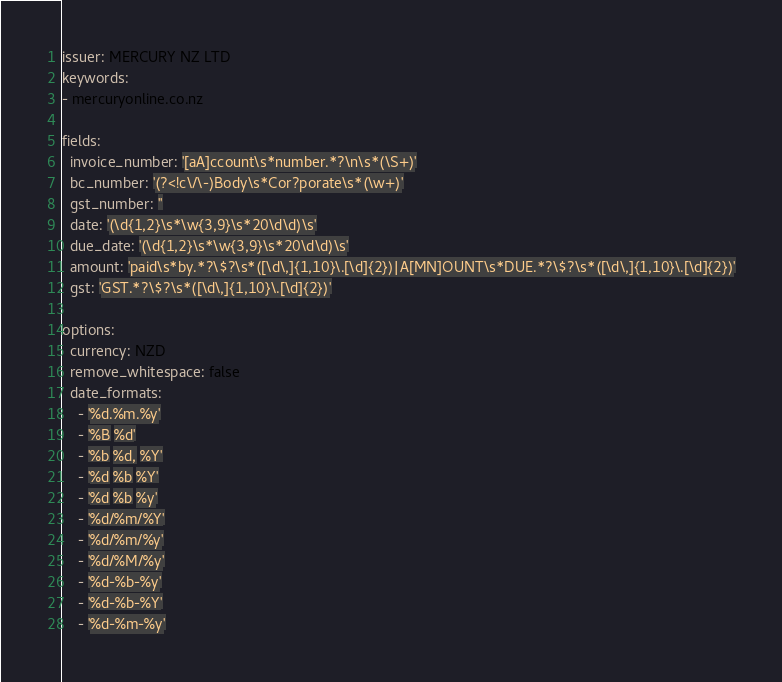<code> <loc_0><loc_0><loc_500><loc_500><_YAML_>issuer: MERCURY NZ LTD
keywords:
- mercuryonline.co.nz

fields: 
  invoice_number: '[aA]ccount\s*number.*?\n\s*(\S+)'
  bc_number: '(?<!c\/\-)Body\s*Cor?porate\s*(\w+)'
  gst_number: ''
  date: '(\d{1,2}\s*\w{3,9}\s*20\d\d)\s'
  due_date: '(\d{1,2}\s*\w{3,9}\s*20\d\d)\s'
  amount: 'paid\s*by.*?\$?\s*([\d\,]{1,10}\.[\d]{2})|A[MN]OUNT\s*DUE.*?\$?\s*([\d\,]{1,10}\.[\d]{2})'
  gst: 'GST.*?\$?\s*([\d\,]{1,10}\.[\d]{2})'

options:
  currency: NZD
  remove_whitespace: false
  date_formats:
    - '%d.%m.%y'
    - '%B %d'
    - '%b %d, %Y'
    - '%d %b %Y'
    - '%d %b %y'
    - '%d/%m/%Y'
    - '%d/%m/%y'
    - '%d/%M/%y'
    - '%d-%b-%y'
    - '%d-%b-%Y'
    - '%d-%m-%y'

</code> 